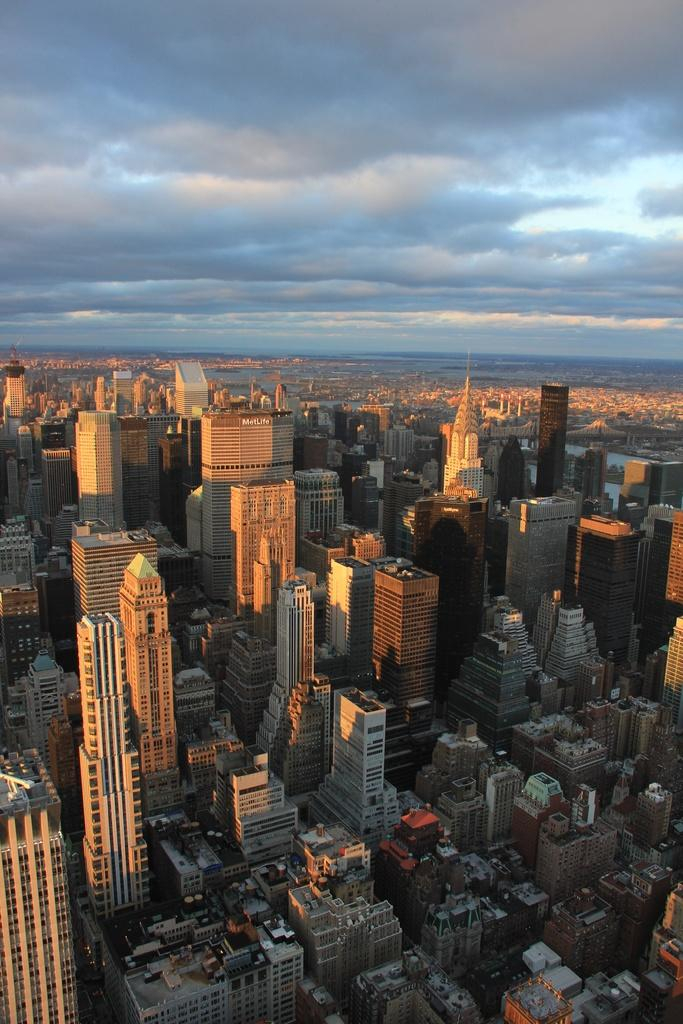What is the main subject of the image? The main subject of the image is an overview of a city. What type of structures can be seen in the image? There are buildings visible in the image. What is the condition of the sky in the image? The sky is covered with clouds in the image. Can you tell me how many toads are visible in the image? There are no toads present in the image; it features an overview of a city with buildings and a cloudy sky. 